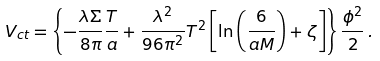Convert formula to latex. <formula><loc_0><loc_0><loc_500><loc_500>V _ { c t } = \left \{ - \frac { \lambda \Sigma } { 8 \pi } \frac { T } { a } + \frac { \lambda ^ { 2 } } { 9 6 \pi ^ { 2 } } T ^ { 2 } \left [ \ln \left ( \frac { 6 } { a M } \right ) + \zeta \right ] \right \} \frac { \phi ^ { 2 } } { 2 } \, .</formula> 